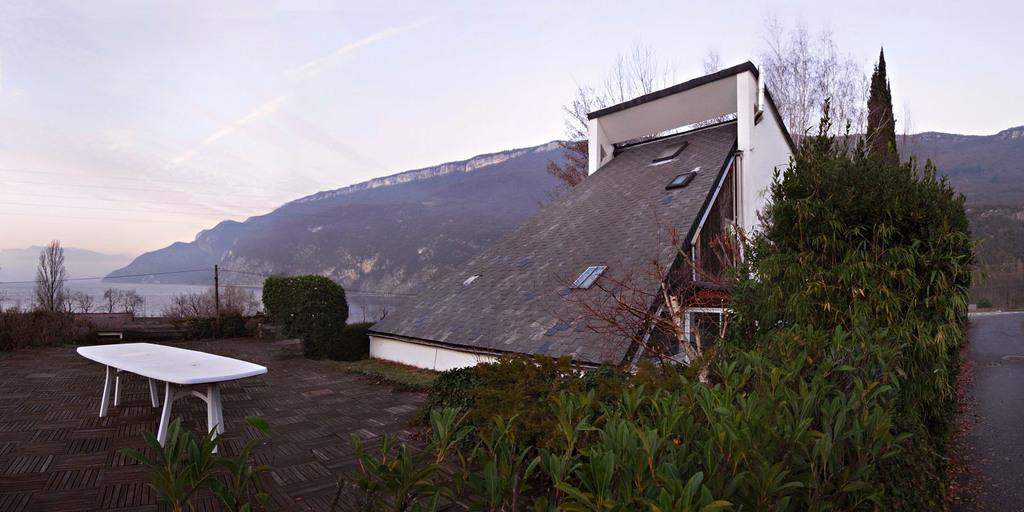What is on the ground in the image? There is a table on the ground in the image. What structure can be seen in the image? There is a shed in the image. What type of vegetation is present in the image? There are plants and trees in the image. What is on the table in the image? There are objects on the table in the image. What can be seen in the background of the image? There are mountains and the sky visible in the background of the image. Can you tell me how many spoons are on the table in the image? There is no mention of spoons in the image; only objects are mentioned on the table. Is there a doctor present in the image? There is no mention of a doctor in the image. 